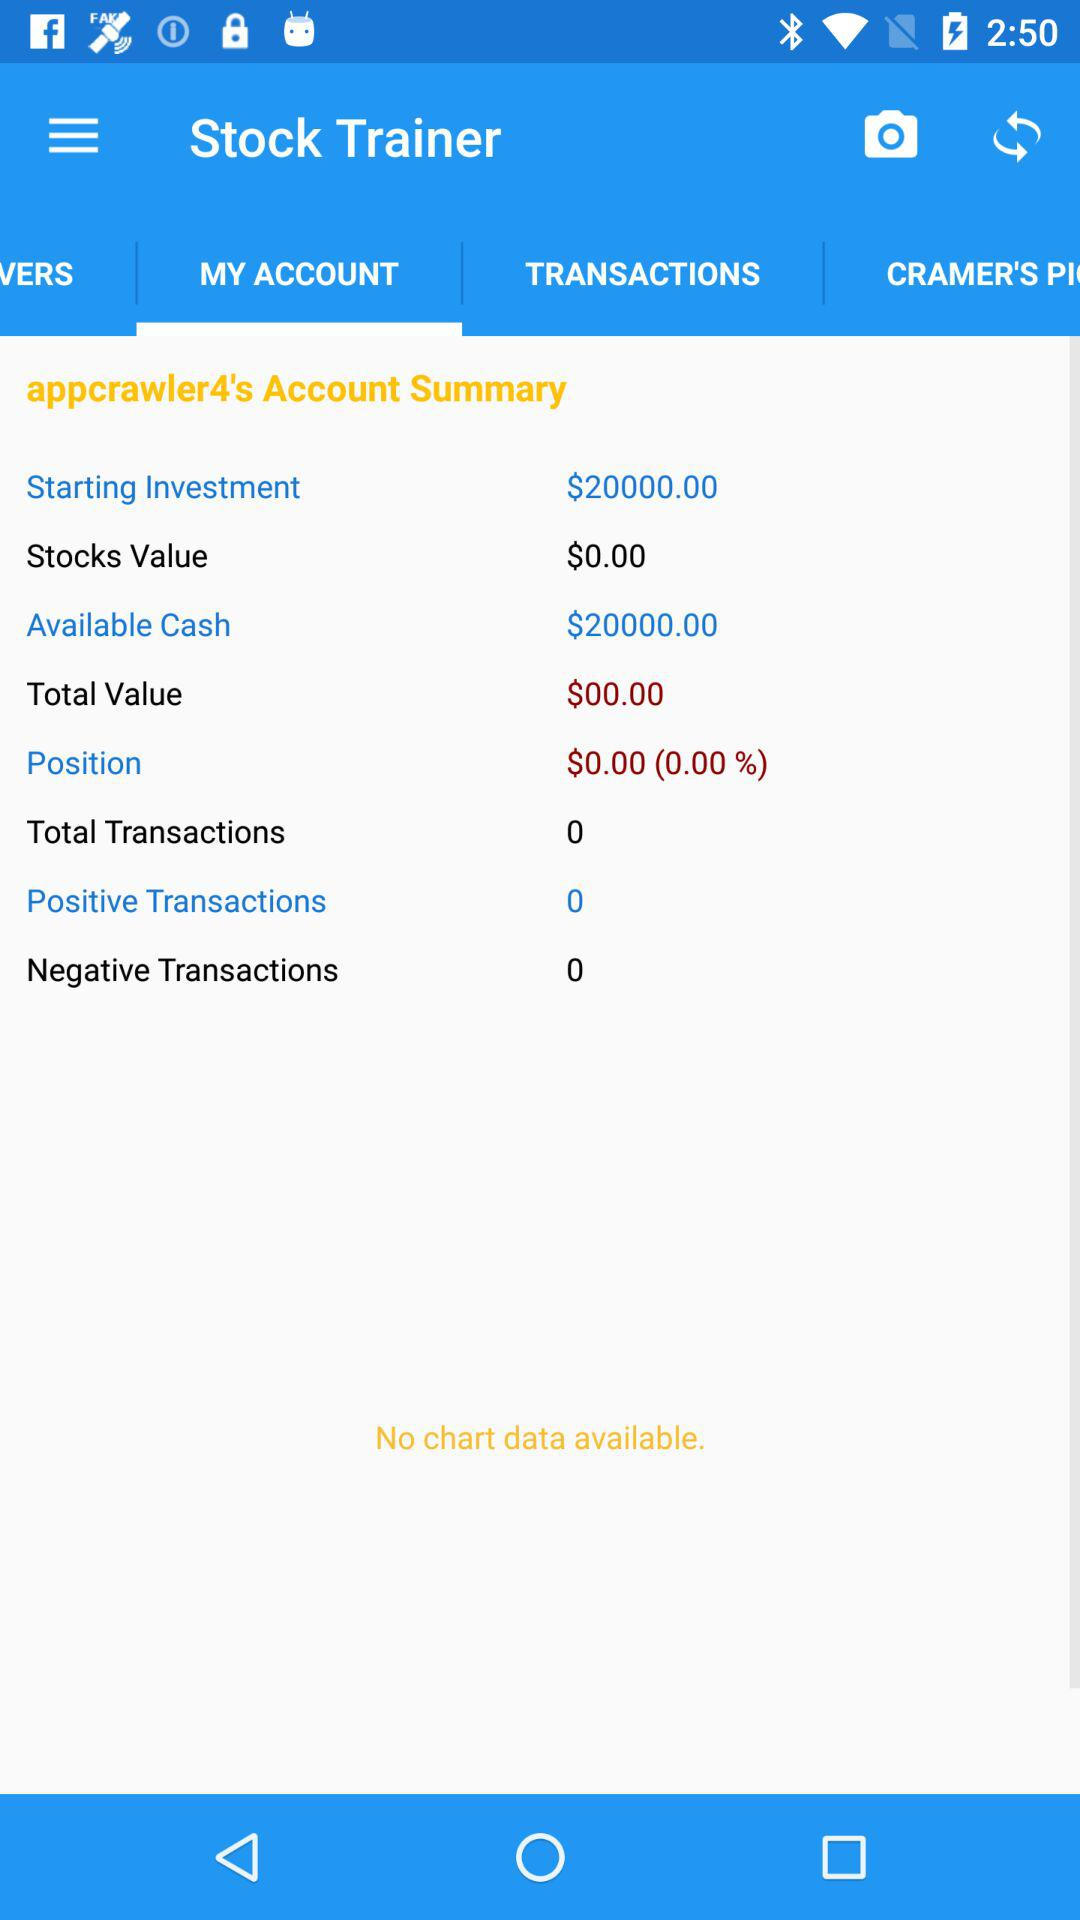How much cash is available? The available cash is $20000. 